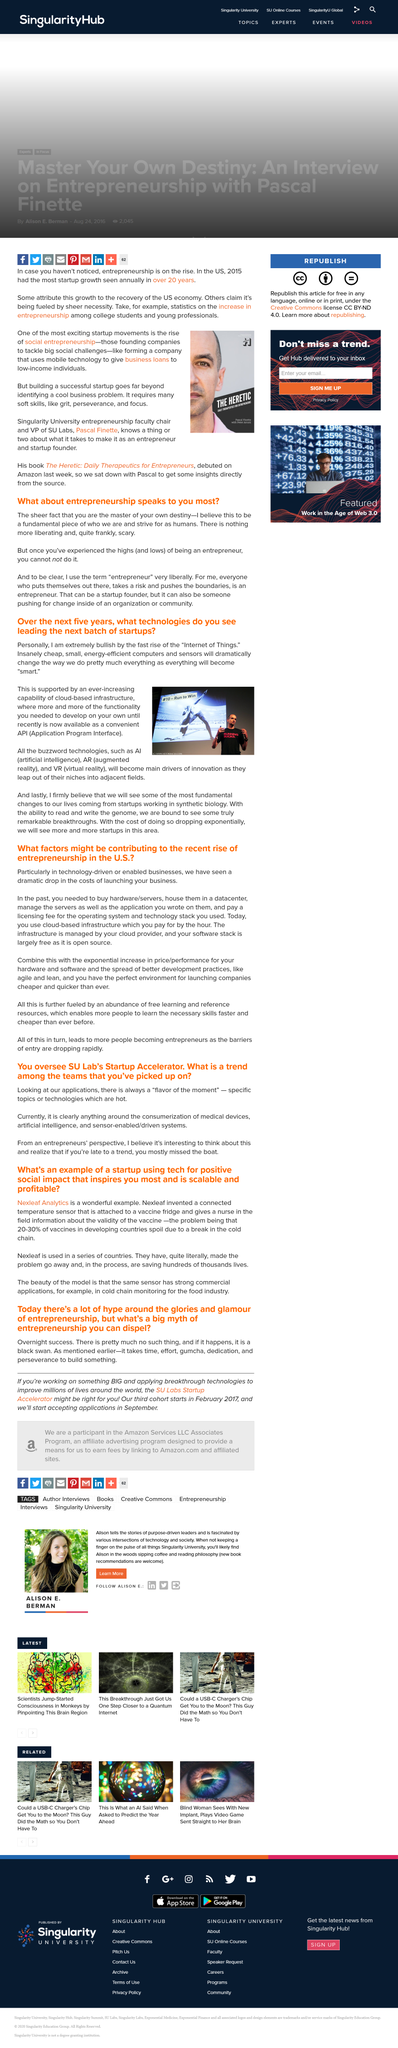Outline some significant characteristics in this image. An entrepreneur experiences highs and lows, including the thrill of success as well as the challenges and setbacks that come with starting and growing a business. Entrepreneurs are masters of their own destiny and have complete control over their own future, as they are the ones who are responsible for making their dreams a reality. The author believes that everyone who takes risks, puts themselves out there, and pushes the boundaries is an entrepreneur. In the past 20 years, 2015 has seen the most significant growth in startup activity in the United States. It is important to possess certain soft skills in order to successfully launch and maintain a startup. Grit, perseverance, and focus are some of the key soft skills that are essential for achieving success in this field. 